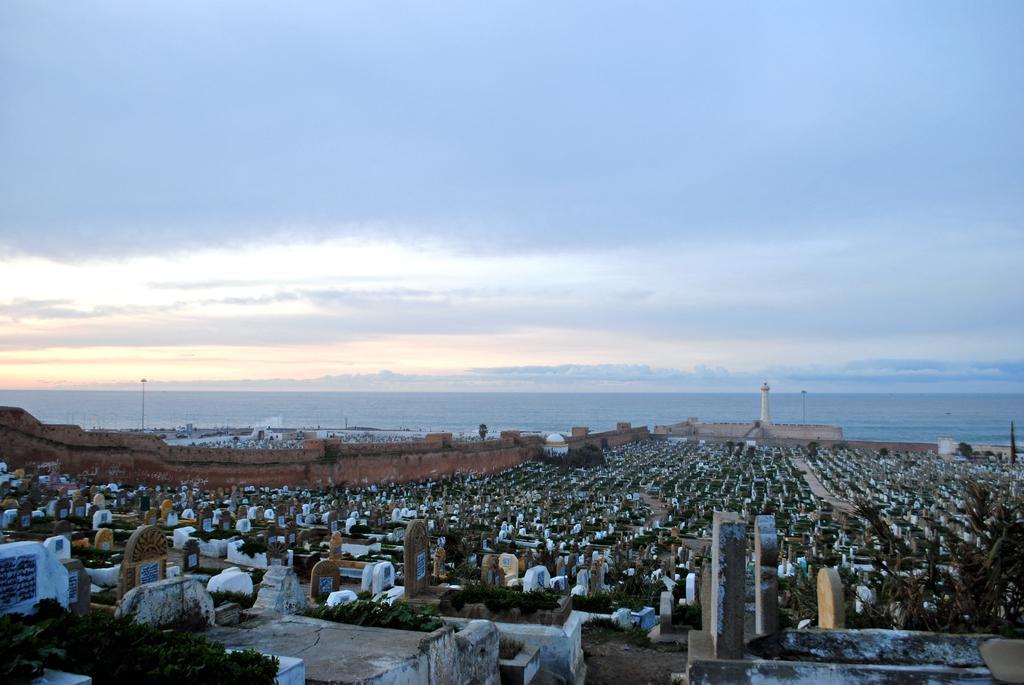In one or two sentences, can you explain what this image depicts? In the image we can see there is a graveyard and behind there is a lighthouse near the seashore. There is a clear sky. 